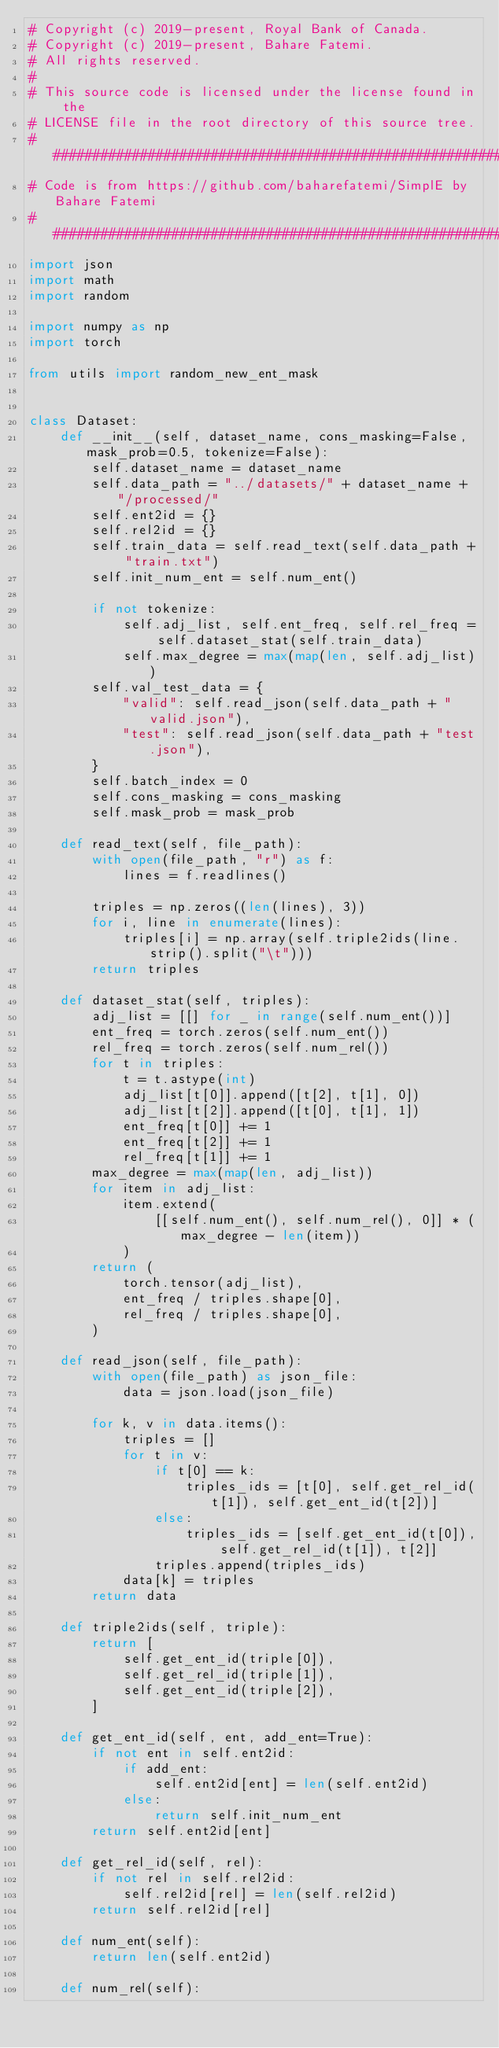Convert code to text. <code><loc_0><loc_0><loc_500><loc_500><_Python_># Copyright (c) 2019-present, Royal Bank of Canada.
# Copyright (c) 2019-present, Bahare Fatemi.
# All rights reserved.
#
# This source code is licensed under the license found in the
# LICENSE file in the root directory of this source tree.
#####################################################################################
# Code is from https://github.com/baharefatemi/SimplE by Bahare Fatemi
####################################################################################
import json
import math
import random

import numpy as np
import torch

from utils import random_new_ent_mask


class Dataset:
    def __init__(self, dataset_name, cons_masking=False, mask_prob=0.5, tokenize=False):
        self.dataset_name = dataset_name
        self.data_path = "../datasets/" + dataset_name + "/processed/"
        self.ent2id = {}
        self.rel2id = {}
        self.train_data = self.read_text(self.data_path + "train.txt")
        self.init_num_ent = self.num_ent()

        if not tokenize:
            self.adj_list, self.ent_freq, self.rel_freq = self.dataset_stat(self.train_data)
            self.max_degree = max(map(len, self.adj_list))
        self.val_test_data = {
            "valid": self.read_json(self.data_path + "valid.json"),
            "test": self.read_json(self.data_path + "test.json"),
        }
        self.batch_index = 0
        self.cons_masking = cons_masking
        self.mask_prob = mask_prob

    def read_text(self, file_path):
        with open(file_path, "r") as f:
            lines = f.readlines()

        triples = np.zeros((len(lines), 3))
        for i, line in enumerate(lines):
            triples[i] = np.array(self.triple2ids(line.strip().split("\t")))
        return triples

    def dataset_stat(self, triples):
        adj_list = [[] for _ in range(self.num_ent())]
        ent_freq = torch.zeros(self.num_ent())
        rel_freq = torch.zeros(self.num_rel())
        for t in triples:
            t = t.astype(int)
            adj_list[t[0]].append([t[2], t[1], 0])
            adj_list[t[2]].append([t[0], t[1], 1])
            ent_freq[t[0]] += 1
            ent_freq[t[2]] += 1
            rel_freq[t[1]] += 1
        max_degree = max(map(len, adj_list))
        for item in adj_list:
            item.extend(
                [[self.num_ent(), self.num_rel(), 0]] * (max_degree - len(item))
            )
        return (
            torch.tensor(adj_list),
            ent_freq / triples.shape[0],
            rel_freq / triples.shape[0],
        )

    def read_json(self, file_path):
        with open(file_path) as json_file:
            data = json.load(json_file)

        for k, v in data.items():
            triples = []
            for t in v:
                if t[0] == k:
                    triples_ids = [t[0], self.get_rel_id(t[1]), self.get_ent_id(t[2])]
                else:
                    triples_ids = [self.get_ent_id(t[0]), self.get_rel_id(t[1]), t[2]]
                triples.append(triples_ids)
            data[k] = triples
        return data

    def triple2ids(self, triple):
        return [
            self.get_ent_id(triple[0]),
            self.get_rel_id(triple[1]),
            self.get_ent_id(triple[2]),
        ]

    def get_ent_id(self, ent, add_ent=True):
        if not ent in self.ent2id:
            if add_ent:
                self.ent2id[ent] = len(self.ent2id)
            else:
                return self.init_num_ent
        return self.ent2id[ent]

    def get_rel_id(self, rel):
        if not rel in self.rel2id:
            self.rel2id[rel] = len(self.rel2id)
        return self.rel2id[rel]

    def num_ent(self):
        return len(self.ent2id)

    def num_rel(self):</code> 